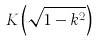Convert formula to latex. <formula><loc_0><loc_0><loc_500><loc_500>K \left ( { \sqrt { 1 - k ^ { 2 } } } \right )</formula> 